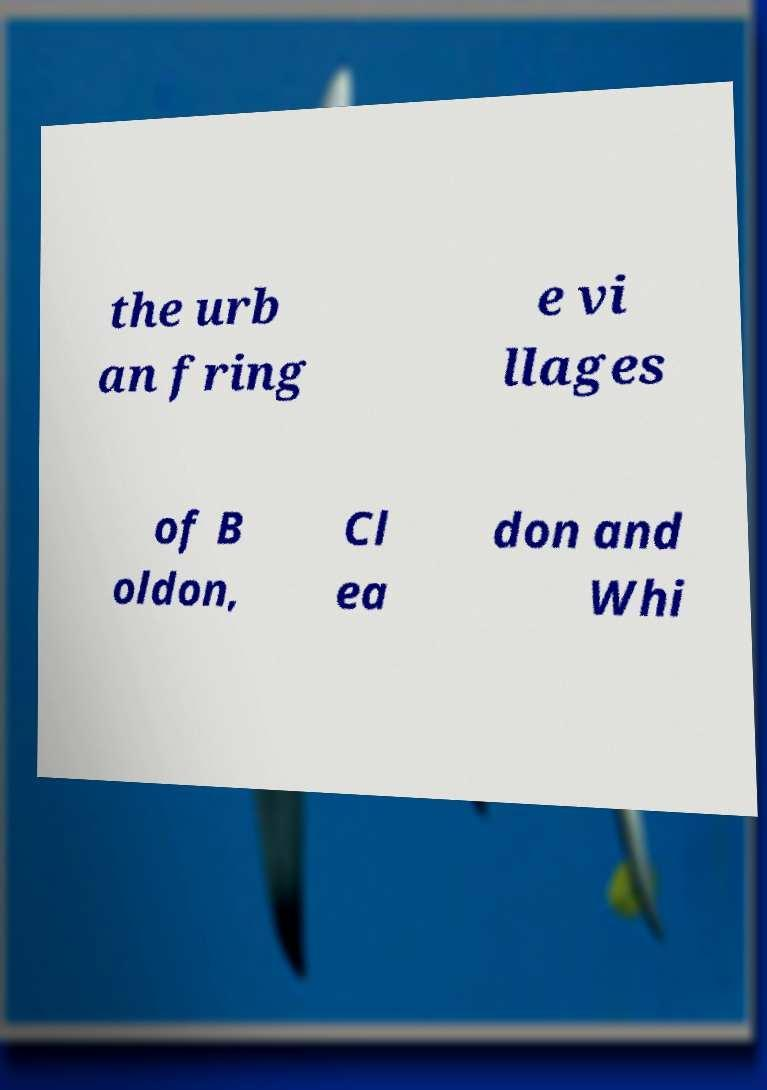Can you accurately transcribe the text from the provided image for me? the urb an fring e vi llages of B oldon, Cl ea don and Whi 